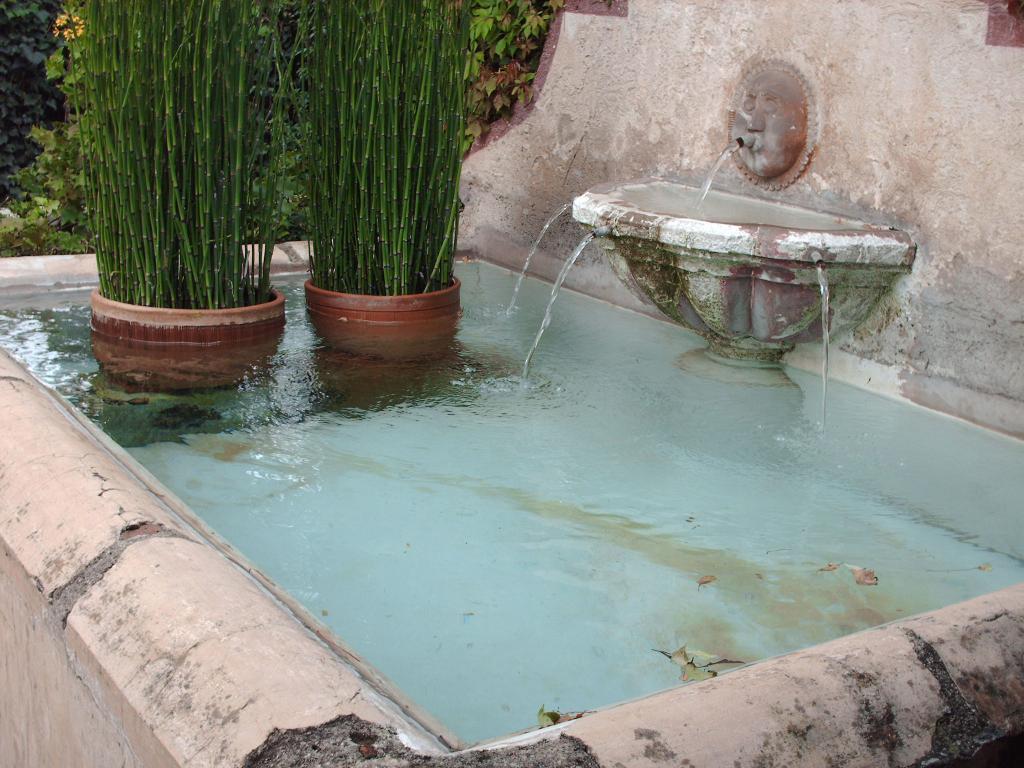Can you describe this image briefly? In this image in the center there is water and there are plants. In the background there are trees. On the right side there is a water fountain. 